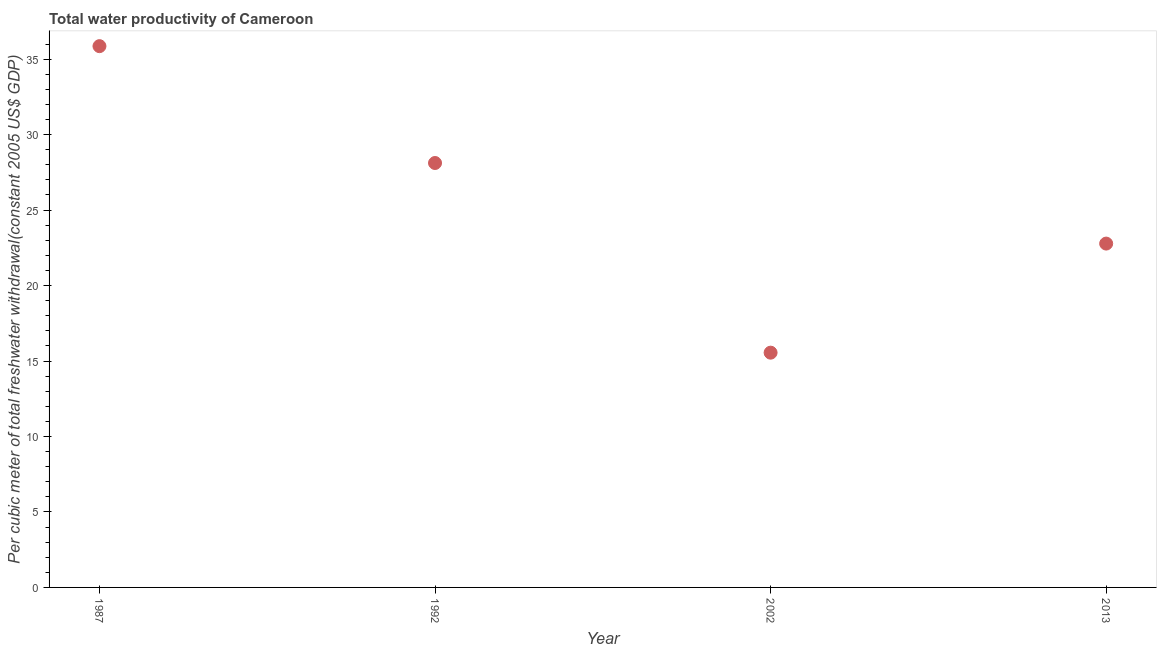What is the total water productivity in 2002?
Offer a terse response. 15.55. Across all years, what is the maximum total water productivity?
Your answer should be very brief. 35.86. Across all years, what is the minimum total water productivity?
Provide a succinct answer. 15.55. In which year was the total water productivity maximum?
Keep it short and to the point. 1987. In which year was the total water productivity minimum?
Make the answer very short. 2002. What is the sum of the total water productivity?
Give a very brief answer. 102.31. What is the difference between the total water productivity in 1992 and 2002?
Keep it short and to the point. 12.57. What is the average total water productivity per year?
Provide a succinct answer. 25.58. What is the median total water productivity?
Offer a very short reply. 25.45. What is the ratio of the total water productivity in 2002 to that in 2013?
Ensure brevity in your answer.  0.68. Is the total water productivity in 1987 less than that in 2013?
Your response must be concise. No. Is the difference between the total water productivity in 1992 and 2002 greater than the difference between any two years?
Your answer should be very brief. No. What is the difference between the highest and the second highest total water productivity?
Provide a succinct answer. 7.74. What is the difference between the highest and the lowest total water productivity?
Ensure brevity in your answer.  20.31. In how many years, is the total water productivity greater than the average total water productivity taken over all years?
Your answer should be compact. 2. Are the values on the major ticks of Y-axis written in scientific E-notation?
Make the answer very short. No. Does the graph contain any zero values?
Make the answer very short. No. What is the title of the graph?
Your answer should be very brief. Total water productivity of Cameroon. What is the label or title of the X-axis?
Keep it short and to the point. Year. What is the label or title of the Y-axis?
Your answer should be very brief. Per cubic meter of total freshwater withdrawal(constant 2005 US$ GDP). What is the Per cubic meter of total freshwater withdrawal(constant 2005 US$ GDP) in 1987?
Make the answer very short. 35.86. What is the Per cubic meter of total freshwater withdrawal(constant 2005 US$ GDP) in 1992?
Offer a very short reply. 28.12. What is the Per cubic meter of total freshwater withdrawal(constant 2005 US$ GDP) in 2002?
Provide a short and direct response. 15.55. What is the Per cubic meter of total freshwater withdrawal(constant 2005 US$ GDP) in 2013?
Offer a terse response. 22.78. What is the difference between the Per cubic meter of total freshwater withdrawal(constant 2005 US$ GDP) in 1987 and 1992?
Make the answer very short. 7.74. What is the difference between the Per cubic meter of total freshwater withdrawal(constant 2005 US$ GDP) in 1987 and 2002?
Offer a terse response. 20.31. What is the difference between the Per cubic meter of total freshwater withdrawal(constant 2005 US$ GDP) in 1987 and 2013?
Give a very brief answer. 13.08. What is the difference between the Per cubic meter of total freshwater withdrawal(constant 2005 US$ GDP) in 1992 and 2002?
Your answer should be very brief. 12.57. What is the difference between the Per cubic meter of total freshwater withdrawal(constant 2005 US$ GDP) in 1992 and 2013?
Ensure brevity in your answer.  5.34. What is the difference between the Per cubic meter of total freshwater withdrawal(constant 2005 US$ GDP) in 2002 and 2013?
Your answer should be compact. -7.23. What is the ratio of the Per cubic meter of total freshwater withdrawal(constant 2005 US$ GDP) in 1987 to that in 1992?
Provide a short and direct response. 1.27. What is the ratio of the Per cubic meter of total freshwater withdrawal(constant 2005 US$ GDP) in 1987 to that in 2002?
Offer a terse response. 2.31. What is the ratio of the Per cubic meter of total freshwater withdrawal(constant 2005 US$ GDP) in 1987 to that in 2013?
Offer a terse response. 1.57. What is the ratio of the Per cubic meter of total freshwater withdrawal(constant 2005 US$ GDP) in 1992 to that in 2002?
Ensure brevity in your answer.  1.81. What is the ratio of the Per cubic meter of total freshwater withdrawal(constant 2005 US$ GDP) in 1992 to that in 2013?
Provide a short and direct response. 1.23. What is the ratio of the Per cubic meter of total freshwater withdrawal(constant 2005 US$ GDP) in 2002 to that in 2013?
Your answer should be compact. 0.68. 